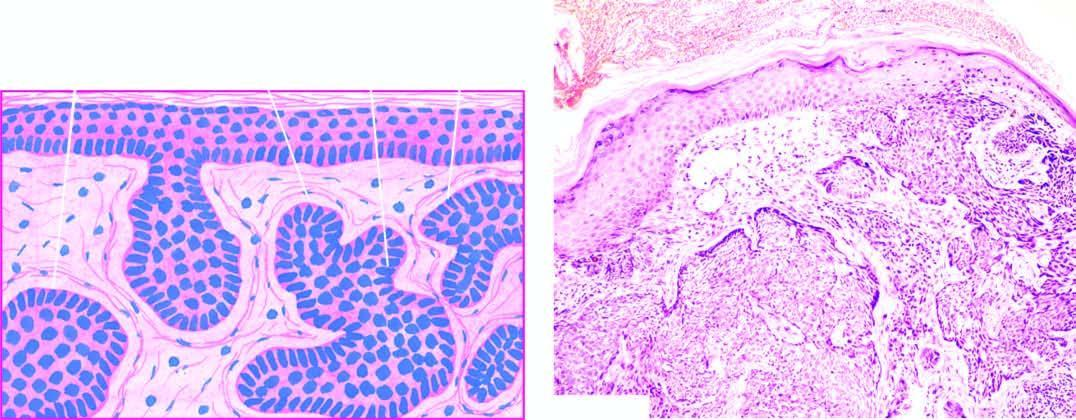what is the dermis invaded by?
Answer the question using a single word or phrase. Irregular masses of basaloid cells with characteristic peripheral palisaded appearance 